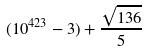Convert formula to latex. <formula><loc_0><loc_0><loc_500><loc_500>( 1 0 ^ { 4 2 3 } - 3 ) + \frac { \sqrt { 1 3 6 } } { 5 }</formula> 